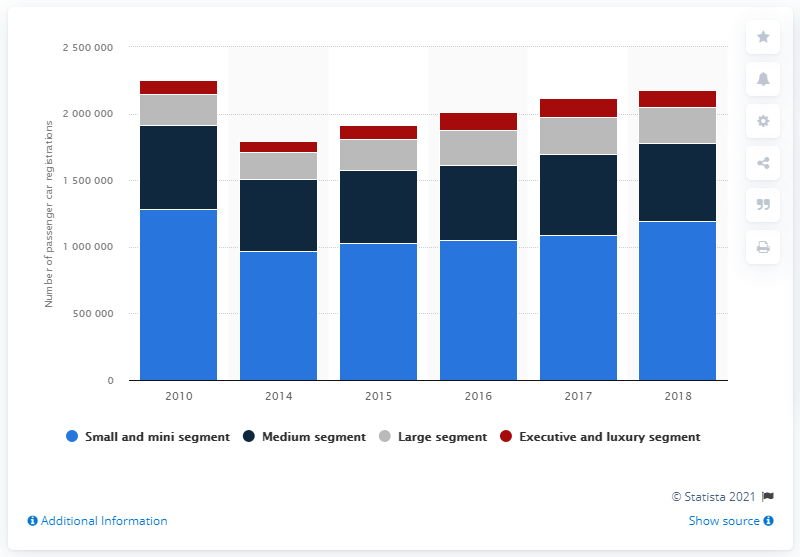Indicate a few pertinent items in this graphic. In 2016, a total of 105,215 small and mini cars were registered in France. 